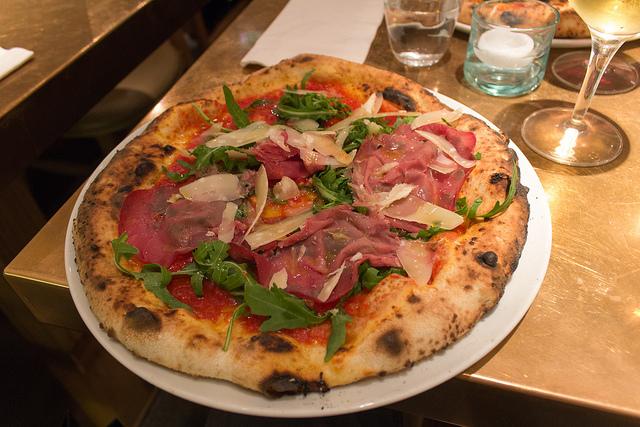Is the pizza pan all the way on the table?
Keep it brief. No. What kind of toppings are on the pizza?
Concise answer only. Veggies/meat. How many pizzas are shown?
Be succinct. 1. How many plates are there?
Keep it brief. 1. What is this person drinking?
Short answer required. Wine. 